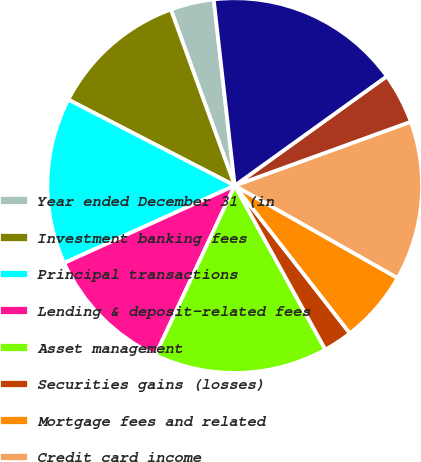Convert chart. <chart><loc_0><loc_0><loc_500><loc_500><pie_chart><fcel>Year ended December 31 (in<fcel>Investment banking fees<fcel>Principal transactions<fcel>Lending & deposit-related fees<fcel>Asset management<fcel>Securities gains (losses)<fcel>Mortgage fees and related<fcel>Credit card income<fcel>Other income<fcel>Noninterest revenue<nl><fcel>3.75%<fcel>11.87%<fcel>14.37%<fcel>11.25%<fcel>15.0%<fcel>2.5%<fcel>6.25%<fcel>13.75%<fcel>4.38%<fcel>16.87%<nl></chart> 